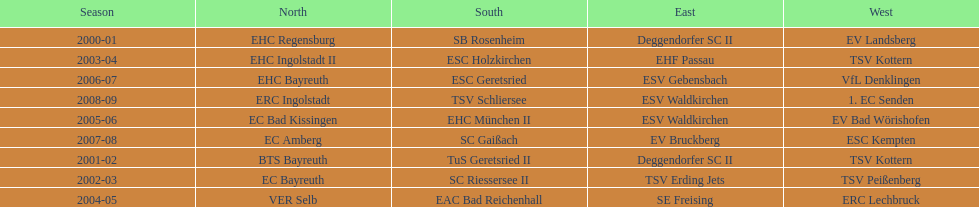Write the full table. {'header': ['Season', 'North', 'South', 'East', 'West'], 'rows': [['2000-01', 'EHC Regensburg', 'SB Rosenheim', 'Deggendorfer SC II', 'EV Landsberg'], ['2003-04', 'EHC Ingolstadt II', 'ESC Holzkirchen', 'EHF Passau', 'TSV Kottern'], ['2006-07', 'EHC Bayreuth', 'ESC Geretsried', 'ESV Gebensbach', 'VfL Denklingen'], ['2008-09', 'ERC Ingolstadt', 'TSV Schliersee', 'ESV Waldkirchen', '1. EC Senden'], ['2005-06', 'EC Bad Kissingen', 'EHC München II', 'ESV Waldkirchen', 'EV Bad Wörishofen'], ['2007-08', 'EC Amberg', 'SC Gaißach', 'EV Bruckberg', 'ESC Kempten'], ['2001-02', 'BTS Bayreuth', 'TuS Geretsried II', 'Deggendorfer SC II', 'TSV Kottern'], ['2002-03', 'EC Bayreuth', 'SC Riessersee II', 'TSV Erding Jets', 'TSV Peißenberg'], ['2004-05', 'VER Selb', 'EAC Bad Reichenhall', 'SE Freising', 'ERC Lechbruck']]} How many champions are listend in the north? 9. 